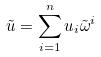<formula> <loc_0><loc_0><loc_500><loc_500>\tilde { u } = \sum _ { i = 1 } ^ { n } u _ { i } \tilde { \omega } ^ { i }</formula> 